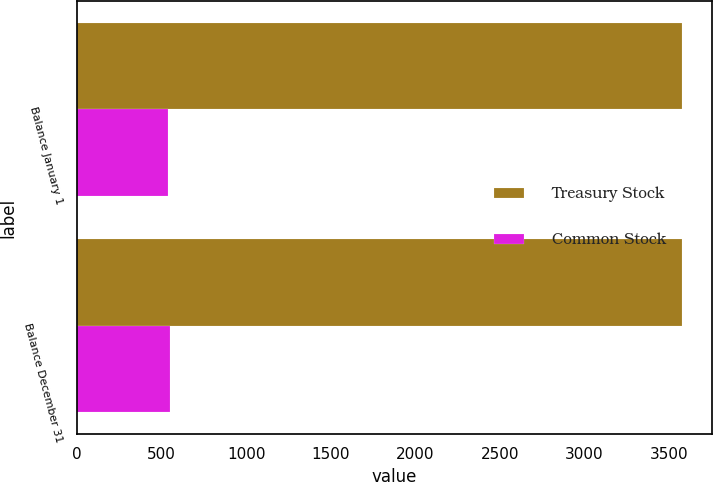Convert chart to OTSL. <chart><loc_0><loc_0><loc_500><loc_500><stacked_bar_chart><ecel><fcel>Balance January 1<fcel>Balance December 31<nl><fcel>Treasury Stock<fcel>3577<fcel>3577<nl><fcel>Common Stock<fcel>536<fcel>550<nl></chart> 